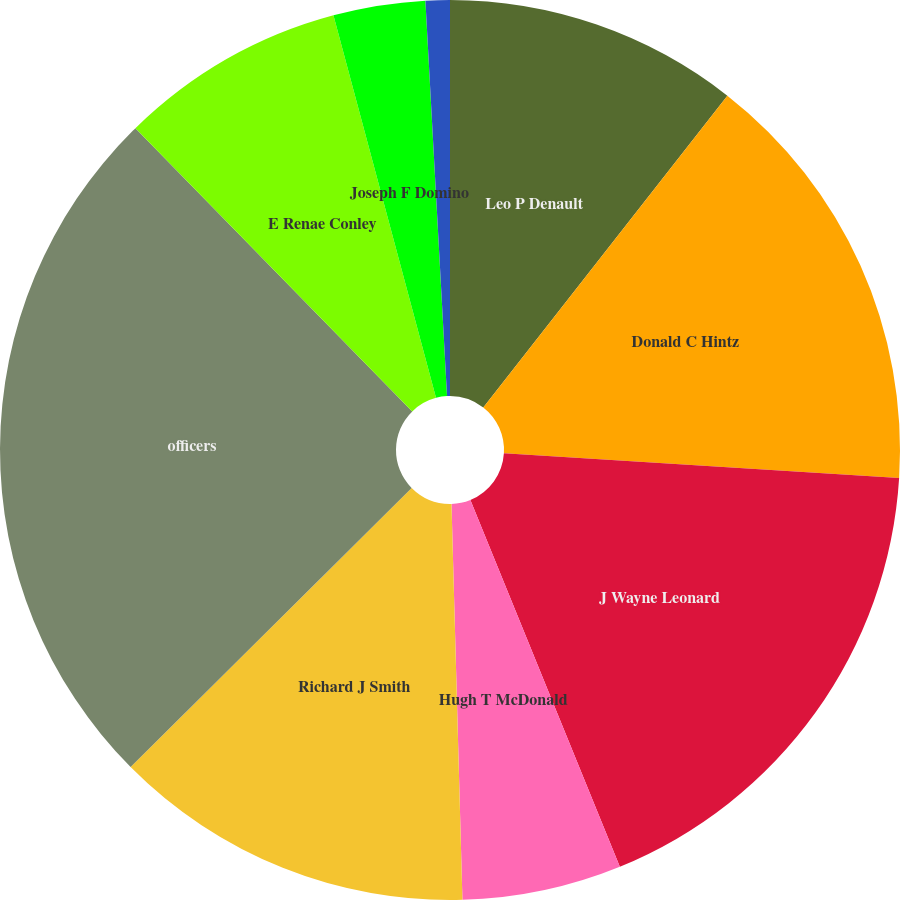Convert chart. <chart><loc_0><loc_0><loc_500><loc_500><pie_chart><fcel>Leo P Denault<fcel>Donald C Hintz<fcel>J Wayne Leonard<fcel>Hugh T McDonald<fcel>Richard J Smith<fcel>officers<fcel>E Renae Conley<fcel>Joseph F Domino<fcel>Carolyn C Shanks<nl><fcel>10.57%<fcel>15.42%<fcel>17.85%<fcel>5.72%<fcel>13.0%<fcel>25.12%<fcel>8.15%<fcel>3.3%<fcel>0.87%<nl></chart> 